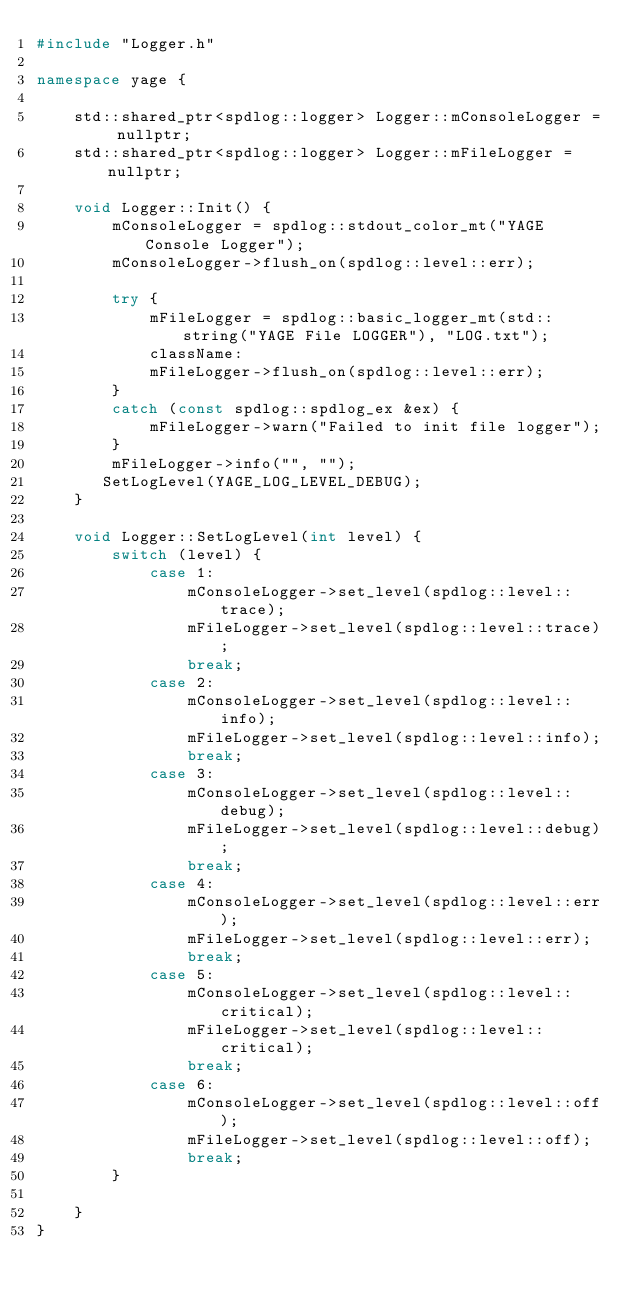Convert code to text. <code><loc_0><loc_0><loc_500><loc_500><_C++_>#include "Logger.h"

namespace yage {

    std::shared_ptr<spdlog::logger> Logger::mConsoleLogger = nullptr;
    std::shared_ptr<spdlog::logger> Logger::mFileLogger = nullptr;

    void Logger::Init() {
        mConsoleLogger = spdlog::stdout_color_mt("YAGE Console Logger");
        mConsoleLogger->flush_on(spdlog::level::err);

        try {
            mFileLogger = spdlog::basic_logger_mt(std::string("YAGE File LOGGER"), "LOG.txt");
            className:
            mFileLogger->flush_on(spdlog::level::err);
        }
        catch (const spdlog::spdlog_ex &ex) {
            mFileLogger->warn("Failed to init file logger");
        }
        mFileLogger->info("", "");
       SetLogLevel(YAGE_LOG_LEVEL_DEBUG);
    }

    void Logger::SetLogLevel(int level) {
        switch (level) {
            case 1:
                mConsoleLogger->set_level(spdlog::level::trace);
                mFileLogger->set_level(spdlog::level::trace);
                break;
            case 2:
                mConsoleLogger->set_level(spdlog::level::info);
                mFileLogger->set_level(spdlog::level::info);
                break;
            case 3:
                mConsoleLogger->set_level(spdlog::level::debug);
                mFileLogger->set_level(spdlog::level::debug);
                break;
            case 4:
                mConsoleLogger->set_level(spdlog::level::err);
                mFileLogger->set_level(spdlog::level::err);
                break;
            case 5:
                mConsoleLogger->set_level(spdlog::level::critical);
                mFileLogger->set_level(spdlog::level::critical);
                break;
            case 6:
                mConsoleLogger->set_level(spdlog::level::off);
                mFileLogger->set_level(spdlog::level::off);
                break;
        }

    }
}</code> 